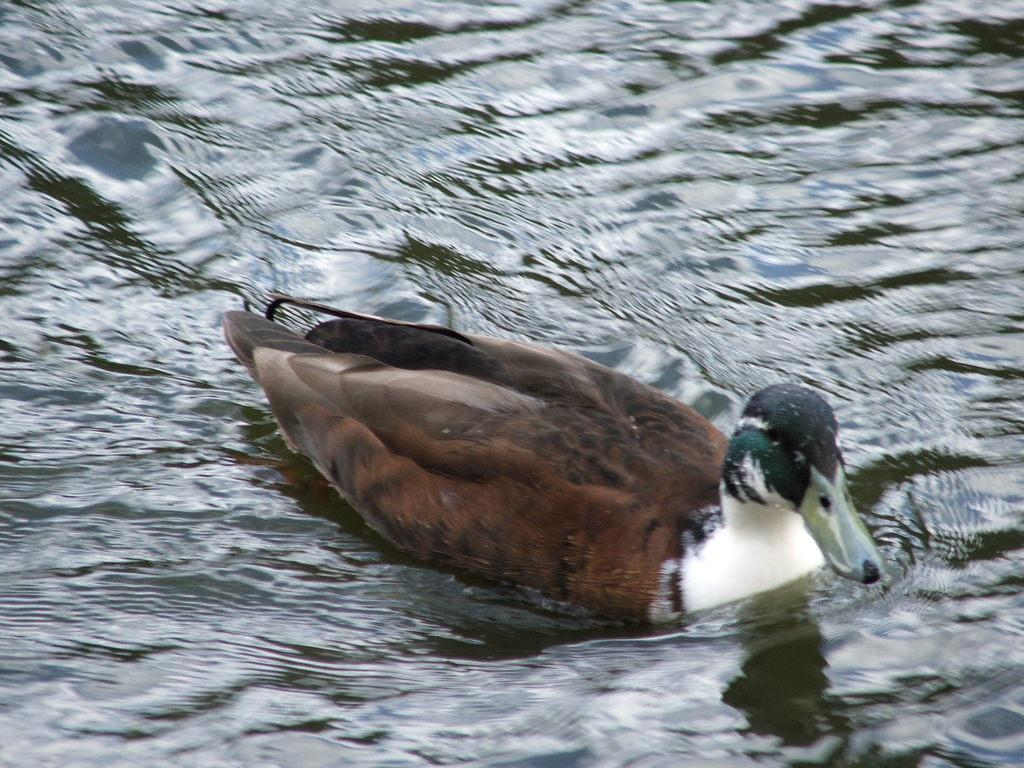What animal is present in the image? There is a duck in the image. What colors can be seen on the duck? The duck has white, brown, and black coloring. What is the duck doing in the image? The duck is swimming in the water. What type of environment is visible in the background of the image? There is a body of water in the background of the image, which might be a pond. What type of dress is the laborer wearing in the image? There is no laborer or dress present in the image; it features a duck swimming in a body of water. 